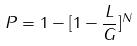Convert formula to latex. <formula><loc_0><loc_0><loc_500><loc_500>P = 1 - [ 1 - \frac { L } { G } ] ^ { N }</formula> 